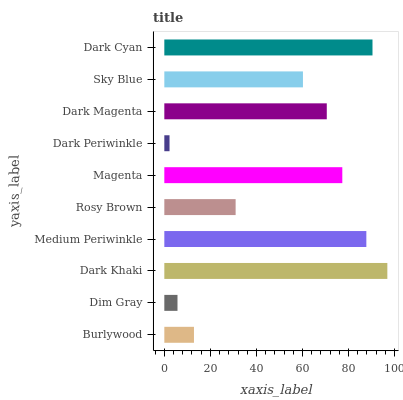Is Dark Periwinkle the minimum?
Answer yes or no. Yes. Is Dark Khaki the maximum?
Answer yes or no. Yes. Is Dim Gray the minimum?
Answer yes or no. No. Is Dim Gray the maximum?
Answer yes or no. No. Is Burlywood greater than Dim Gray?
Answer yes or no. Yes. Is Dim Gray less than Burlywood?
Answer yes or no. Yes. Is Dim Gray greater than Burlywood?
Answer yes or no. No. Is Burlywood less than Dim Gray?
Answer yes or no. No. Is Dark Magenta the high median?
Answer yes or no. Yes. Is Sky Blue the low median?
Answer yes or no. Yes. Is Sky Blue the high median?
Answer yes or no. No. Is Dim Gray the low median?
Answer yes or no. No. 